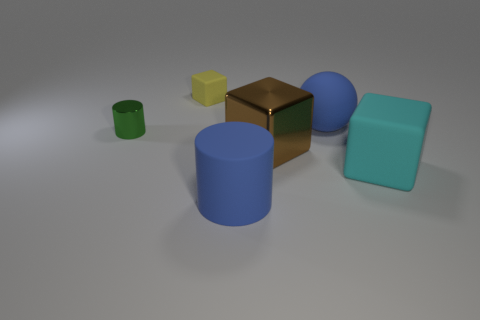What textures do the objects in the image have? All objects in the image appear to have a matte texture, lacking any significant reflection or shine. 